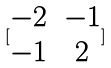<formula> <loc_0><loc_0><loc_500><loc_500>[ \begin{matrix} - 2 & - 1 \\ - 1 & 2 \end{matrix} ]</formula> 